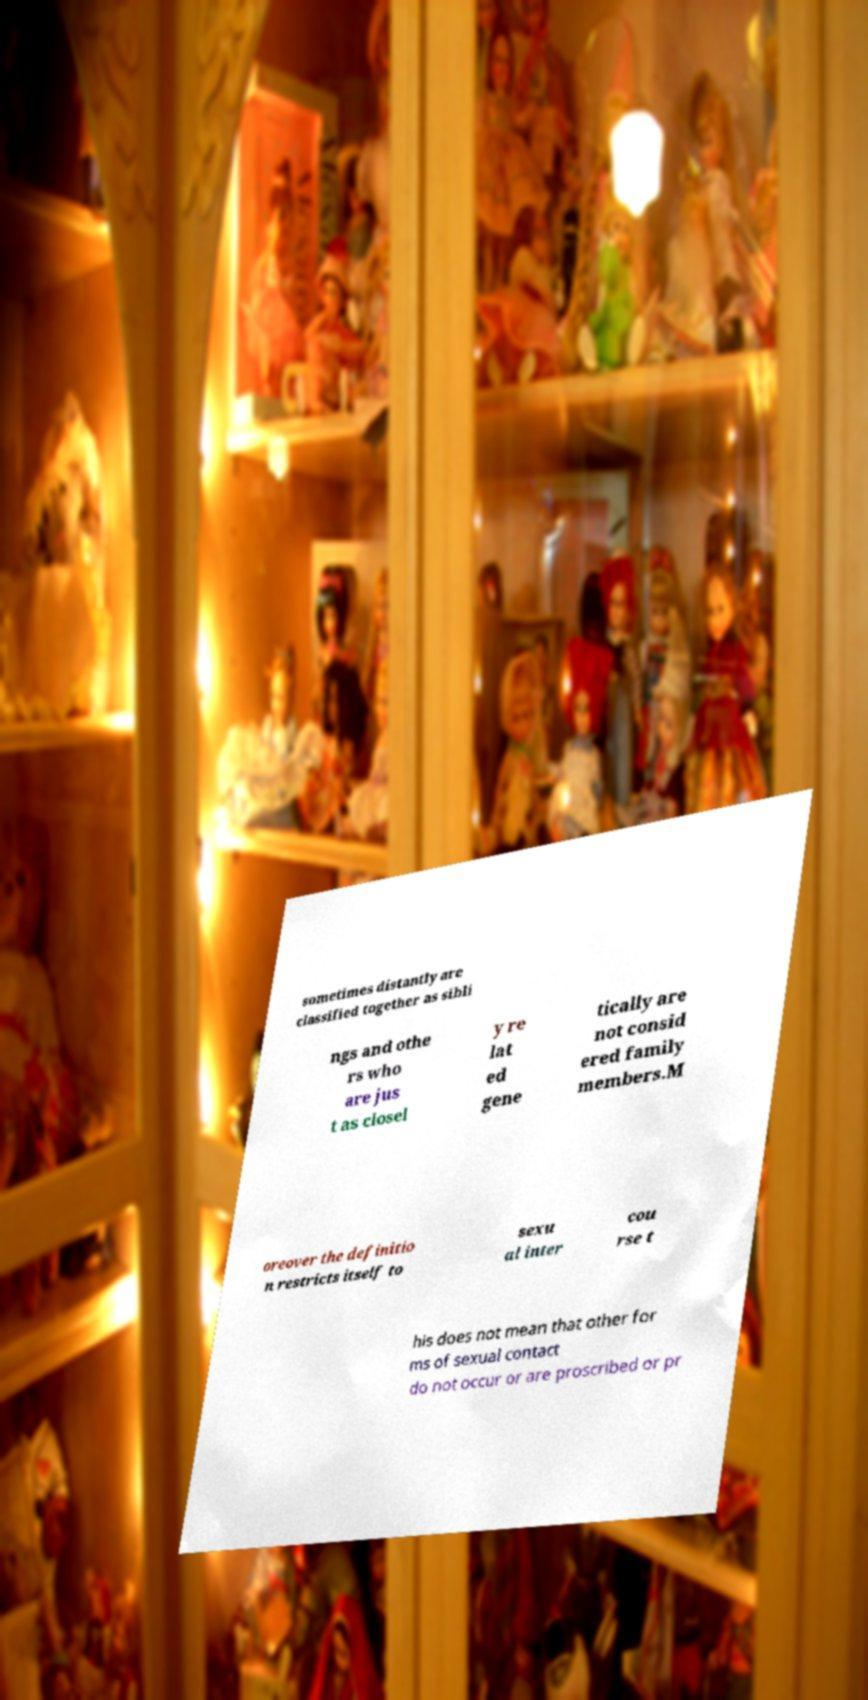Could you extract and type out the text from this image? sometimes distantly are classified together as sibli ngs and othe rs who are jus t as closel y re lat ed gene tically are not consid ered family members.M oreover the definitio n restricts itself to sexu al inter cou rse t his does not mean that other for ms of sexual contact do not occur or are proscribed or pr 